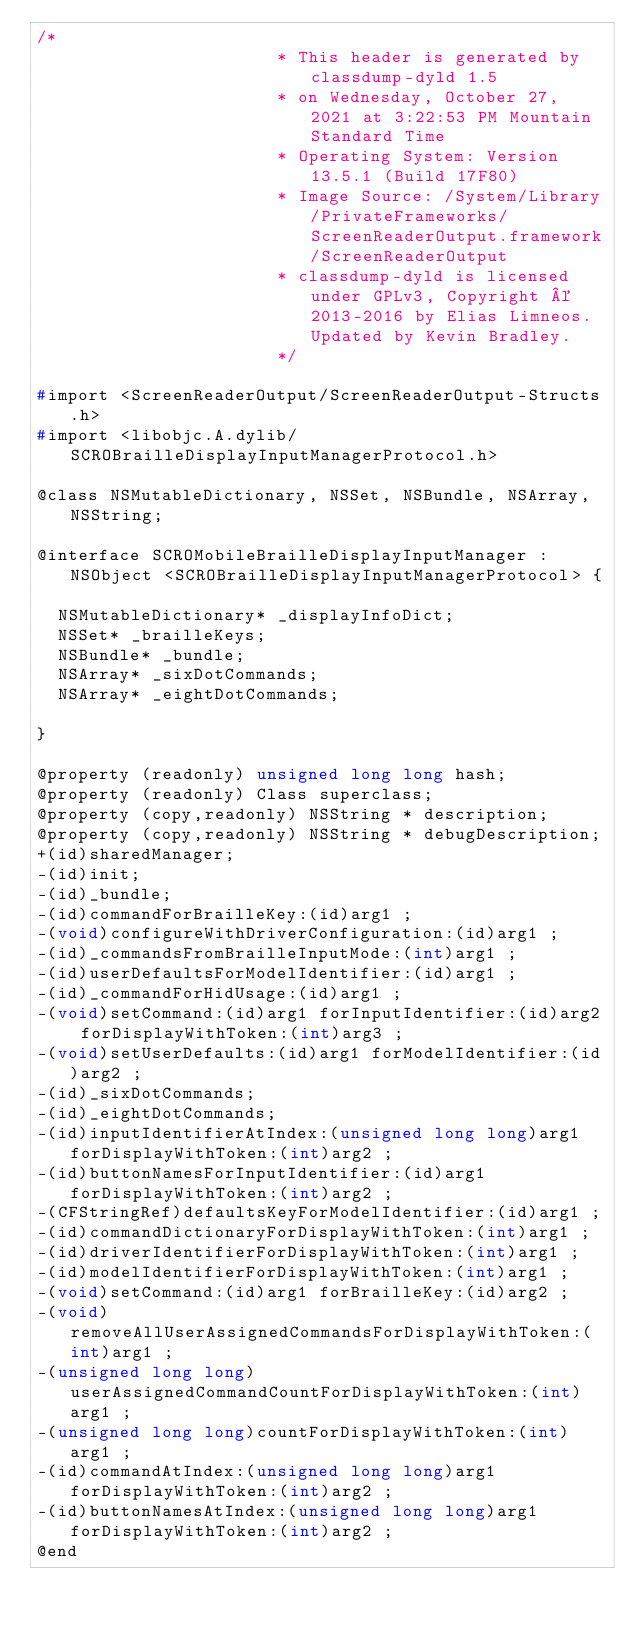<code> <loc_0><loc_0><loc_500><loc_500><_C_>/*
                       * This header is generated by classdump-dyld 1.5
                       * on Wednesday, October 27, 2021 at 3:22:53 PM Mountain Standard Time
                       * Operating System: Version 13.5.1 (Build 17F80)
                       * Image Source: /System/Library/PrivateFrameworks/ScreenReaderOutput.framework/ScreenReaderOutput
                       * classdump-dyld is licensed under GPLv3, Copyright © 2013-2016 by Elias Limneos. Updated by Kevin Bradley.
                       */

#import <ScreenReaderOutput/ScreenReaderOutput-Structs.h>
#import <libobjc.A.dylib/SCROBrailleDisplayInputManagerProtocol.h>

@class NSMutableDictionary, NSSet, NSBundle, NSArray, NSString;

@interface SCROMobileBrailleDisplayInputManager : NSObject <SCROBrailleDisplayInputManagerProtocol> {

	NSMutableDictionary* _displayInfoDict;
	NSSet* _brailleKeys;
	NSBundle* _bundle;
	NSArray* _sixDotCommands;
	NSArray* _eightDotCommands;

}

@property (readonly) unsigned long long hash; 
@property (readonly) Class superclass; 
@property (copy,readonly) NSString * description; 
@property (copy,readonly) NSString * debugDescription; 
+(id)sharedManager;
-(id)init;
-(id)_bundle;
-(id)commandForBrailleKey:(id)arg1 ;
-(void)configureWithDriverConfiguration:(id)arg1 ;
-(id)_commandsFromBrailleInputMode:(int)arg1 ;
-(id)userDefaultsForModelIdentifier:(id)arg1 ;
-(id)_commandForHidUsage:(id)arg1 ;
-(void)setCommand:(id)arg1 forInputIdentifier:(id)arg2 forDisplayWithToken:(int)arg3 ;
-(void)setUserDefaults:(id)arg1 forModelIdentifier:(id)arg2 ;
-(id)_sixDotCommands;
-(id)_eightDotCommands;
-(id)inputIdentifierAtIndex:(unsigned long long)arg1 forDisplayWithToken:(int)arg2 ;
-(id)buttonNamesForInputIdentifier:(id)arg1 forDisplayWithToken:(int)arg2 ;
-(CFStringRef)defaultsKeyForModelIdentifier:(id)arg1 ;
-(id)commandDictionaryForDisplayWithToken:(int)arg1 ;
-(id)driverIdentifierForDisplayWithToken:(int)arg1 ;
-(id)modelIdentifierForDisplayWithToken:(int)arg1 ;
-(void)setCommand:(id)arg1 forBrailleKey:(id)arg2 ;
-(void)removeAllUserAssignedCommandsForDisplayWithToken:(int)arg1 ;
-(unsigned long long)userAssignedCommandCountForDisplayWithToken:(int)arg1 ;
-(unsigned long long)countForDisplayWithToken:(int)arg1 ;
-(id)commandAtIndex:(unsigned long long)arg1 forDisplayWithToken:(int)arg2 ;
-(id)buttonNamesAtIndex:(unsigned long long)arg1 forDisplayWithToken:(int)arg2 ;
@end

</code> 